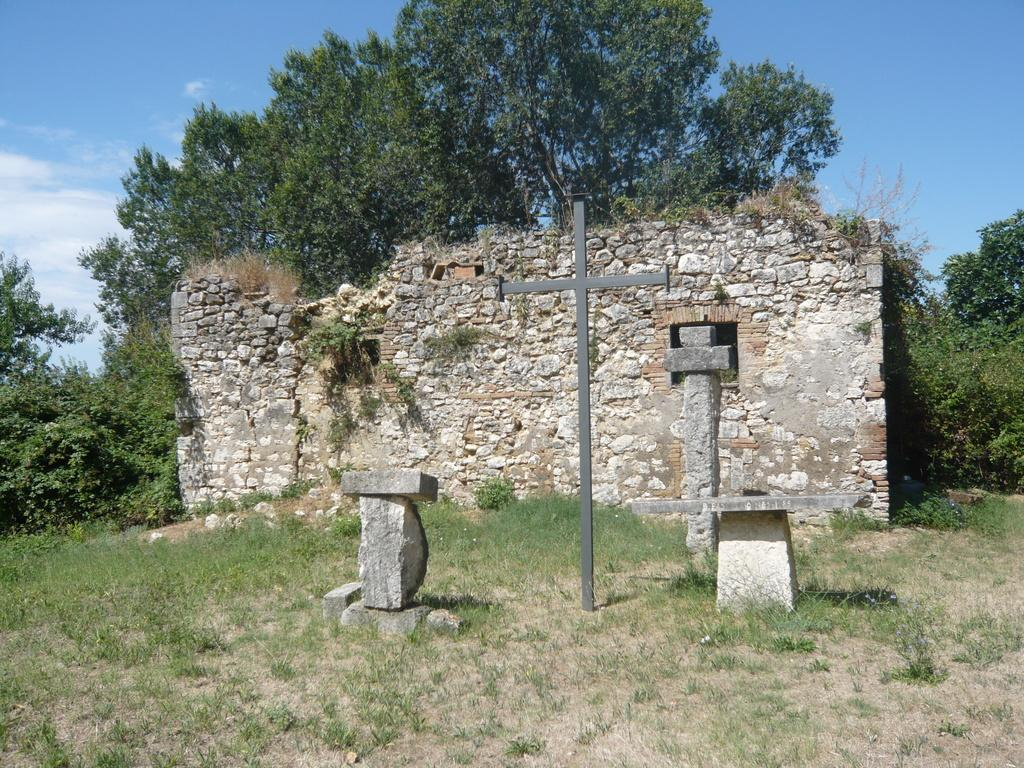What type of natural elements can be seen in the image? There are rocks, grass, and trees visible in the image. What man-made structure is present in the image? There is a wall visible in the image. What religious symbol can be seen in the image? There is a pole in the shape of a holy cross symbol in the image. What part of the natural environment is visible in the image? The sky is visible in the image. Can you hear the fireman's siren in the image? There is no fireman or siren present in the image, so it is not possible to hear a siren. What type of roof is visible in the image? There is no roof present in the image; it features rocks, a wall, grass, trees, and a pole in the shape of a holy cross symbol. 